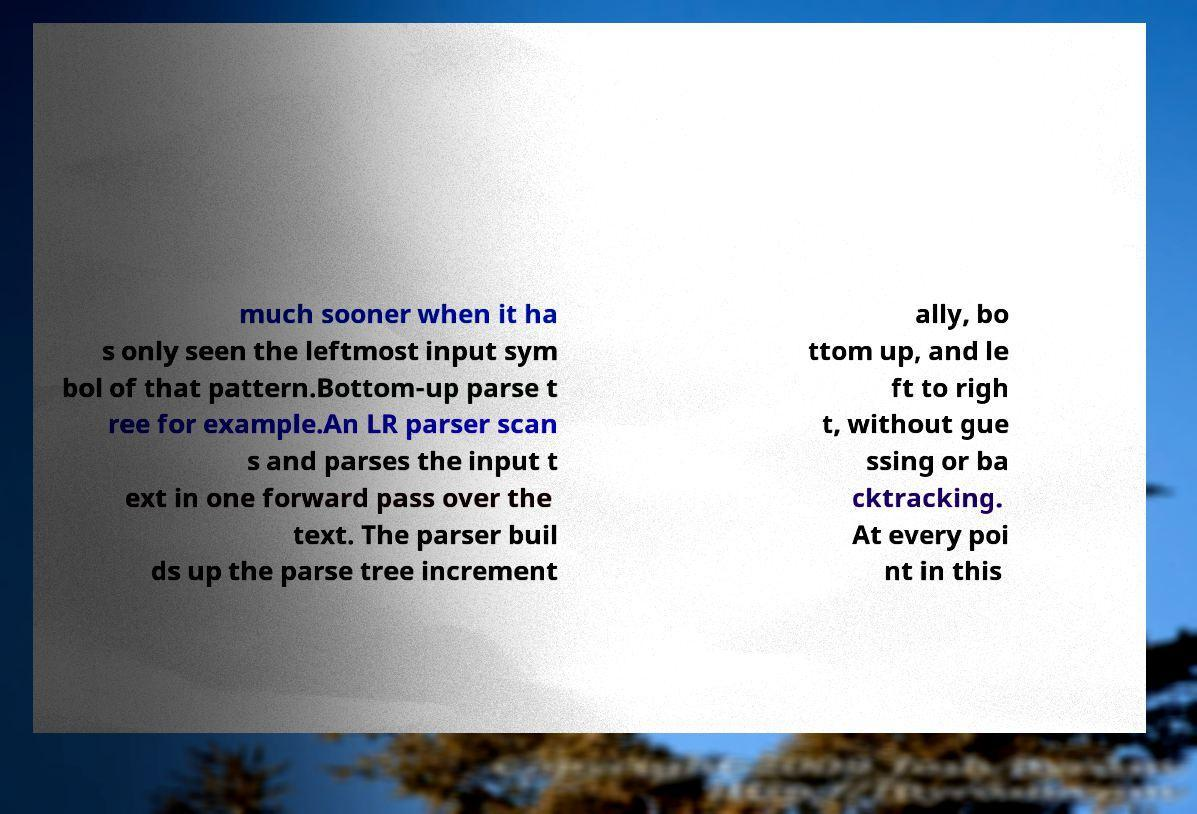Could you extract and type out the text from this image? much sooner when it ha s only seen the leftmost input sym bol of that pattern.Bottom-up parse t ree for example.An LR parser scan s and parses the input t ext in one forward pass over the text. The parser buil ds up the parse tree increment ally, bo ttom up, and le ft to righ t, without gue ssing or ba cktracking. At every poi nt in this 